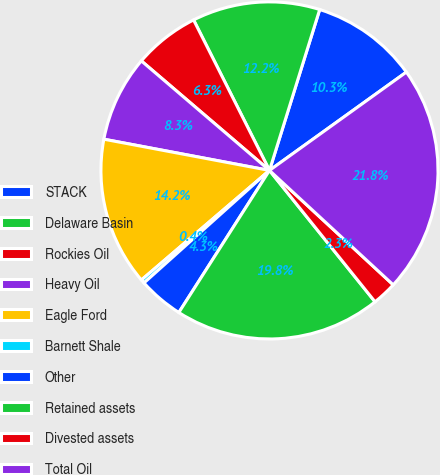Convert chart. <chart><loc_0><loc_0><loc_500><loc_500><pie_chart><fcel>STACK<fcel>Delaware Basin<fcel>Rockies Oil<fcel>Heavy Oil<fcel>Eagle Ford<fcel>Barnett Shale<fcel>Other<fcel>Retained assets<fcel>Divested assets<fcel>Total Oil<nl><fcel>10.27%<fcel>12.25%<fcel>6.31%<fcel>8.29%<fcel>14.23%<fcel>0.37%<fcel>4.33%<fcel>19.81%<fcel>2.35%<fcel>21.79%<nl></chart> 